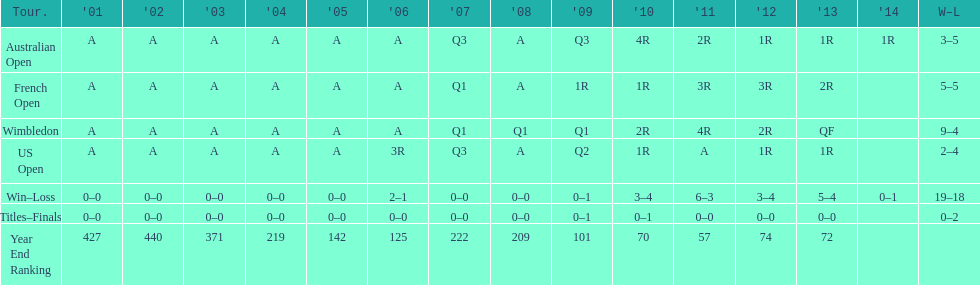Which year end ranking was higher, 2004 or 2011? 2011. 